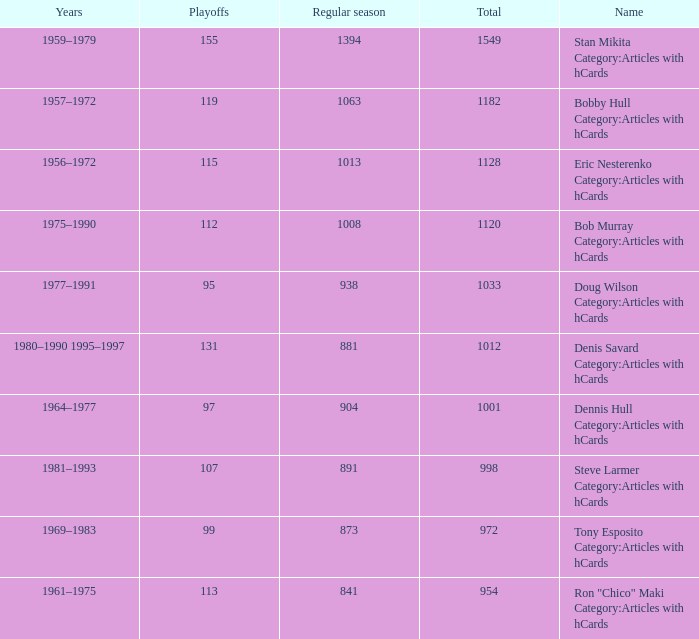Parse the full table. {'header': ['Years', 'Playoffs', 'Regular season', 'Total', 'Name'], 'rows': [['1959–1979', '155', '1394', '1549', 'Stan Mikita Category:Articles with hCards'], ['1957–1972', '119', '1063', '1182', 'Bobby Hull Category:Articles with hCards'], ['1956–1972', '115', '1013', '1128', 'Eric Nesterenko Category:Articles with hCards'], ['1975–1990', '112', '1008', '1120', 'Bob Murray Category:Articles with hCards'], ['1977–1991', '95', '938', '1033', 'Doug Wilson Category:Articles with hCards'], ['1980–1990 1995–1997', '131', '881', '1012', 'Denis Savard Category:Articles with hCards'], ['1964–1977', '97', '904', '1001', 'Dennis Hull Category:Articles with hCards'], ['1981–1993', '107', '891', '998', 'Steve Larmer Category:Articles with hCards'], ['1969–1983', '99', '873', '972', 'Tony Esposito Category:Articles with hCards'], ['1961–1975', '113', '841', '954', 'Ron "Chico" Maki Category:Articles with hCards']]} What is the years when playoffs is 115? 1956–1972. 